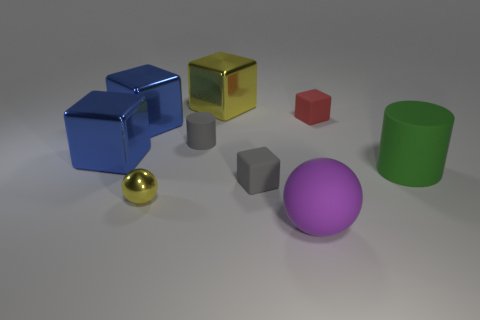Subtract all gray blocks. How many blocks are left? 4 Subtract all yellow blocks. How many blocks are left? 4 Subtract all brown blocks. Subtract all brown cylinders. How many blocks are left? 5 Add 1 large blue metallic cylinders. How many objects exist? 10 Subtract all spheres. How many objects are left? 7 Subtract 1 red cubes. How many objects are left? 8 Subtract all cubes. Subtract all small metal objects. How many objects are left? 3 Add 8 small red cubes. How many small red cubes are left? 9 Add 5 small red matte things. How many small red matte things exist? 6 